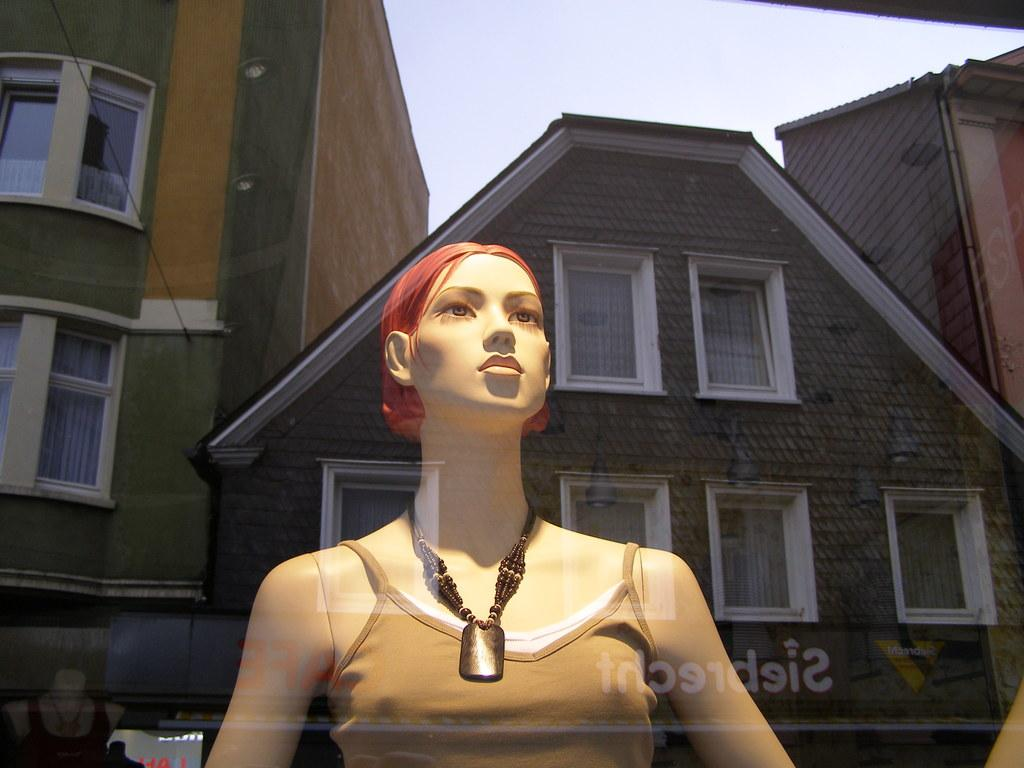What is the main subject of the image? There is a mannequin in the image. What is the mannequin wearing? The mannequin is wearing a chain. What can be seen in the background of the image? There are buildings in the background of the image. What is written or visible at the bottom of the image? There is text visible at the bottom of the image. What is visible at the top of the image? The sky is visible at the top of the image. What type of cap is the mannequin wearing in the image? There is no cap visible on the mannequin in the image. What rate is the mannequin moving at in the image? The mannequin is not moving in the image, so there is no rate to consider. 